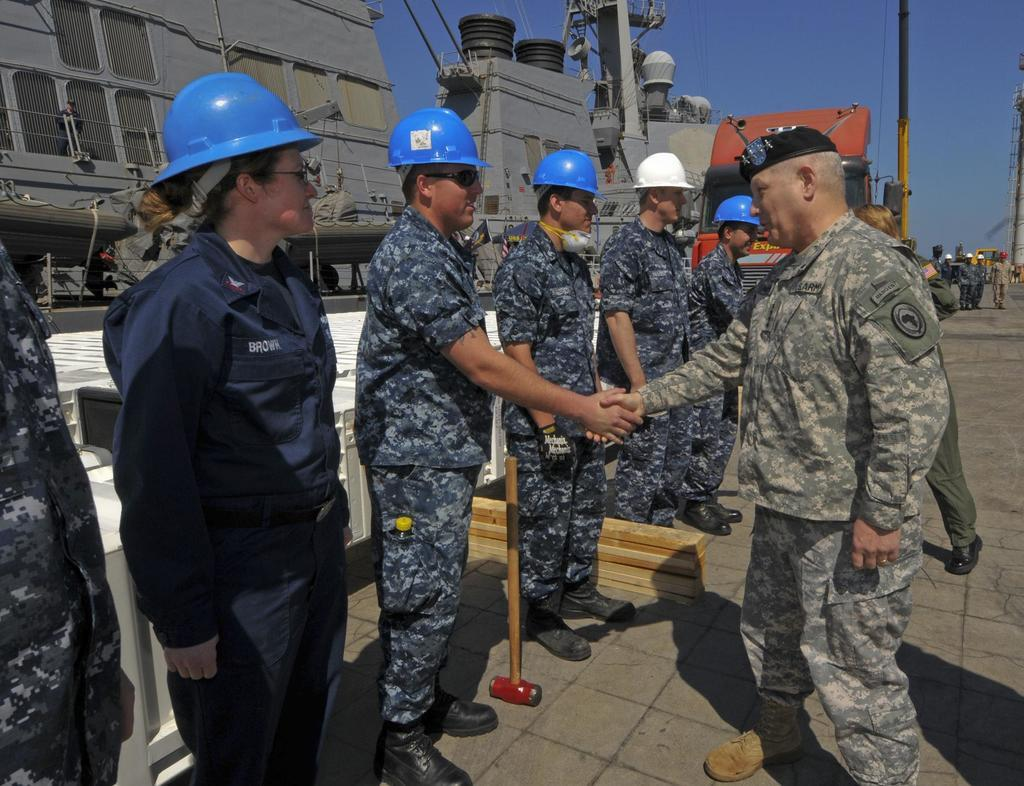How many people are in the image? There are people in the image, but the exact number is not specified. What type of headgear can be seen on some of the people? Some people are wearing helmets in the image. What type of headgear is worn by one person in the image? One person is wearing a cap in the image. What can be seen in the background of the image? Containers are visible in the background of the image. What is visible at the top of the image? The sky is visible in the image. What type of plant is being policed by the officers in the image? There are no officers or plants present in the image. What country is the image taken in? The country where the image was taken is not mentioned in the facts. 